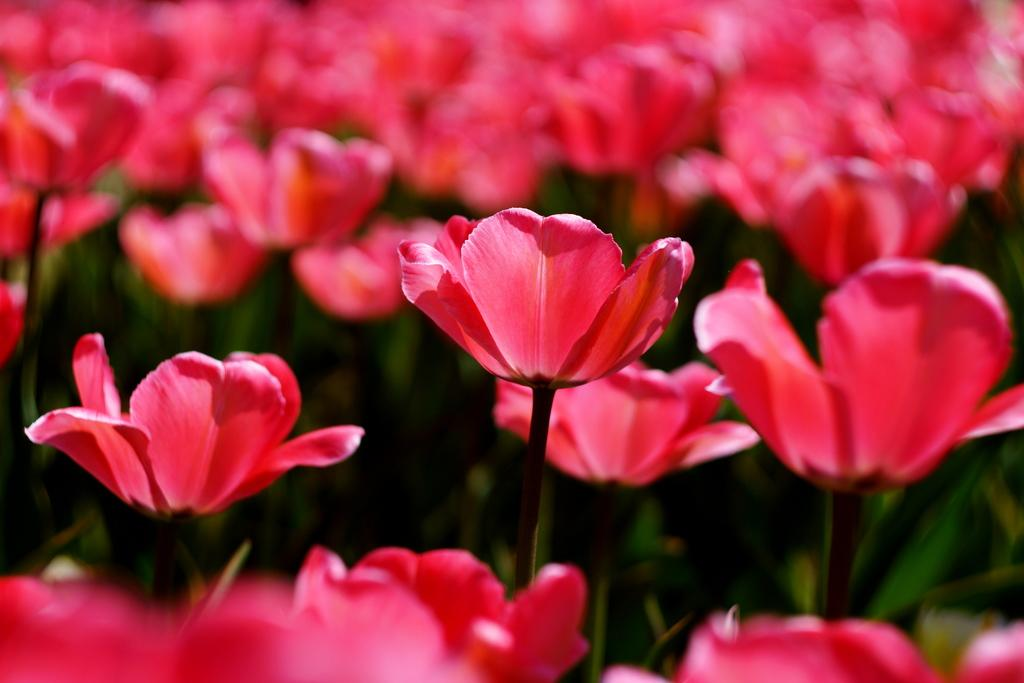What color are the flowers in the image? The flowers in the image are pink. What are the flowers growing on? The flowers are on plants. What type of straw is used to make the flowers in the image? There is no straw present in the image; the flowers are on plants. 